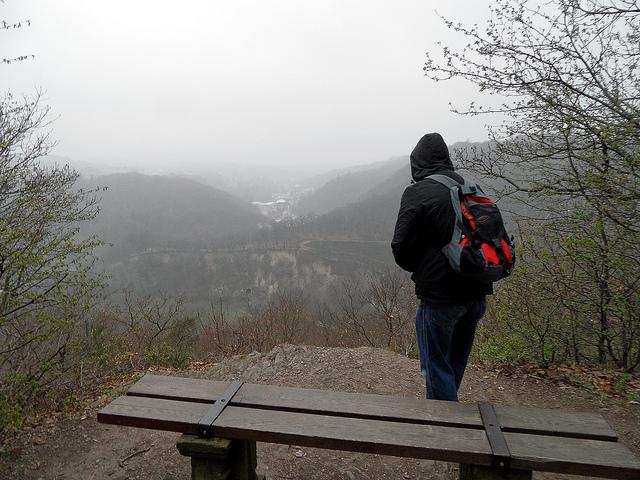What item here can hold the most books?

Choices:
A) luggage
B) bookcase
C) wheelbarrow
D) backpack backpack 